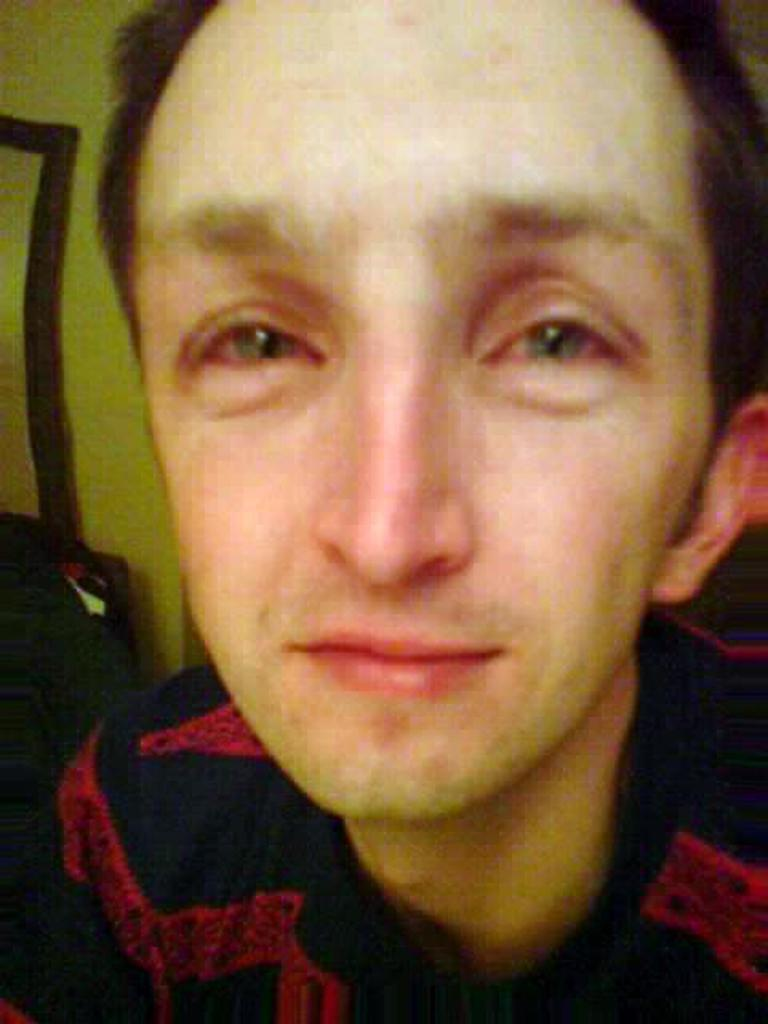What is the main subject of the image? There is a guy in the image. Can you describe any specific features of the guy? The guy has red eyes and a long forehead. What type of vase is on the table next to the guy in the image? There is no vase present in the image; it only features a guy with red eyes and a long forehead. How many elbows does the guy have in the image? The guy has two elbows, as he has two arms, but the number of elbows is not mentioned in the provided facts. 